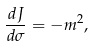<formula> <loc_0><loc_0><loc_500><loc_500>\frac { d J } { d \sigma } = - m ^ { 2 } ,</formula> 